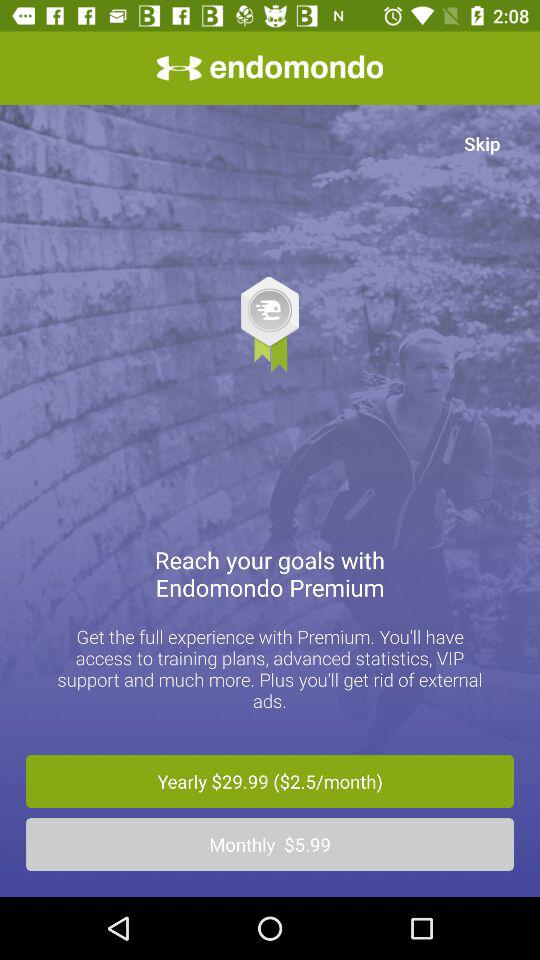What is the charge for the yearly plan? The charge for the yearly plan is $29.99. 